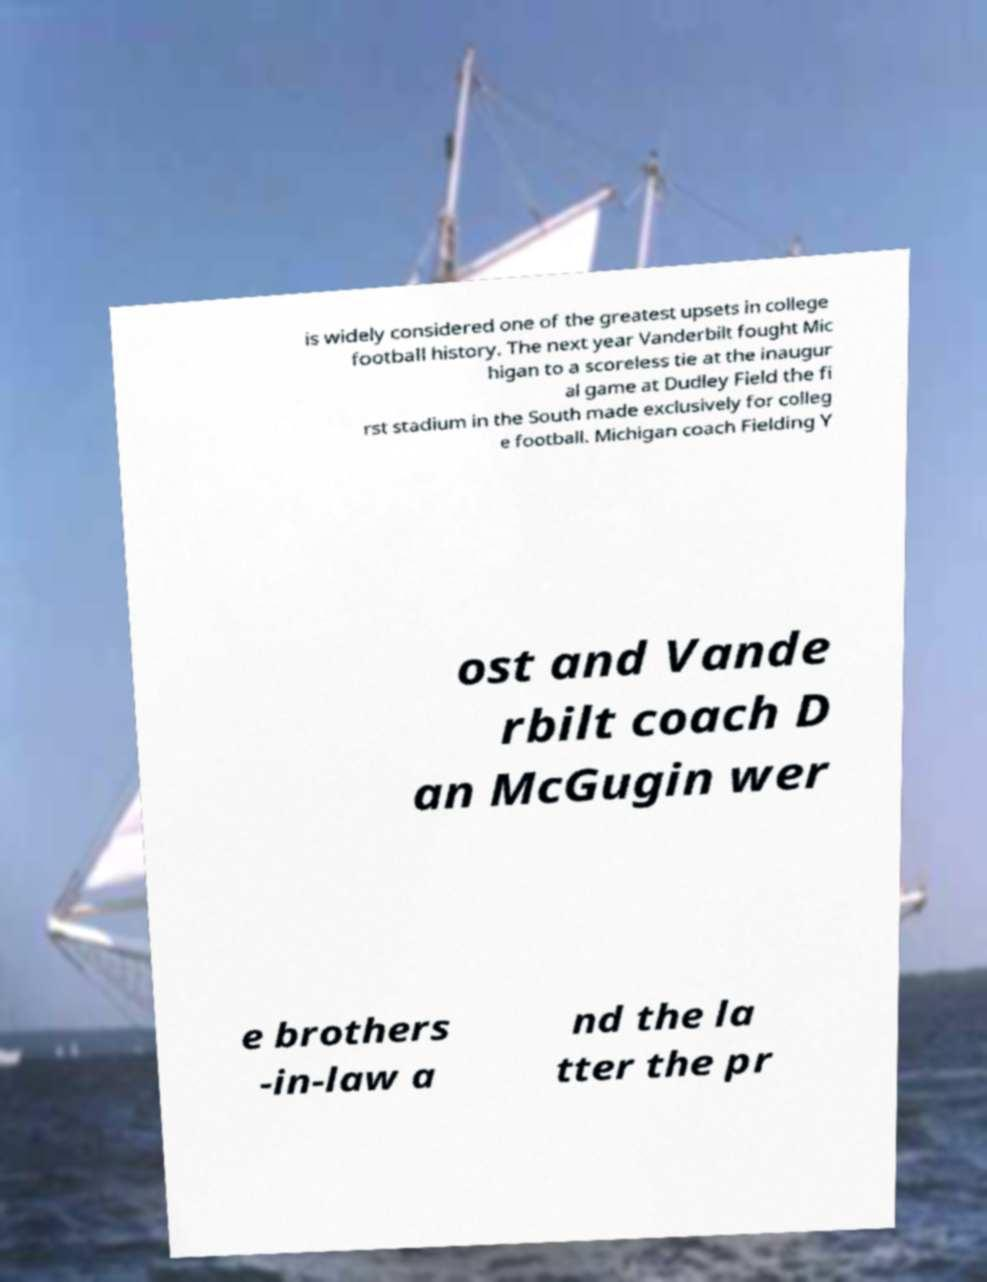Could you extract and type out the text from this image? is widely considered one of the greatest upsets in college football history. The next year Vanderbilt fought Mic higan to a scoreless tie at the inaugur al game at Dudley Field the fi rst stadium in the South made exclusively for colleg e football. Michigan coach Fielding Y ost and Vande rbilt coach D an McGugin wer e brothers -in-law a nd the la tter the pr 